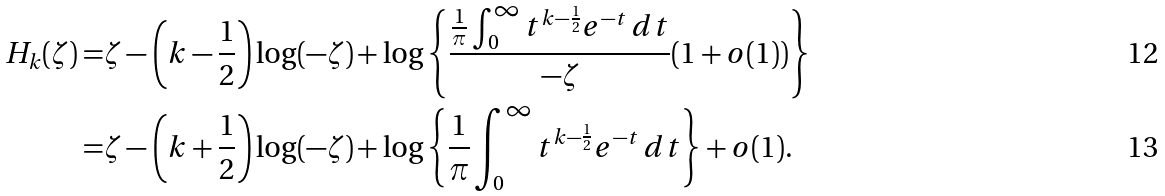<formula> <loc_0><loc_0><loc_500><loc_500>H _ { k } ( \zeta ) = & \zeta - \left ( k - \frac { 1 } { 2 } \right ) \log ( - \zeta ) + \log \left \{ \frac { \frac { 1 } { \pi } \int _ { 0 } ^ { \infty } t ^ { k - \frac { 1 } { 2 } } e ^ { - t } \, d t } { - \zeta } ( 1 + o ( 1 ) ) \right \} \\ = & \zeta - \left ( k + \frac { 1 } { 2 } \right ) \log ( - \zeta ) + \log \left \{ \frac { 1 } { \pi } \int _ { 0 } ^ { \infty } t ^ { k - \frac { 1 } { 2 } } e ^ { - t } \, d t \right \} + o ( 1 ) .</formula> 